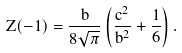<formula> <loc_0><loc_0><loc_500><loc_500>Z ( - 1 ) = \frac { b } { 8 \sqrt { \pi } } \left ( \frac { c ^ { 2 } } { b ^ { 2 } } + \frac { 1 } { 6 } \right ) .</formula> 